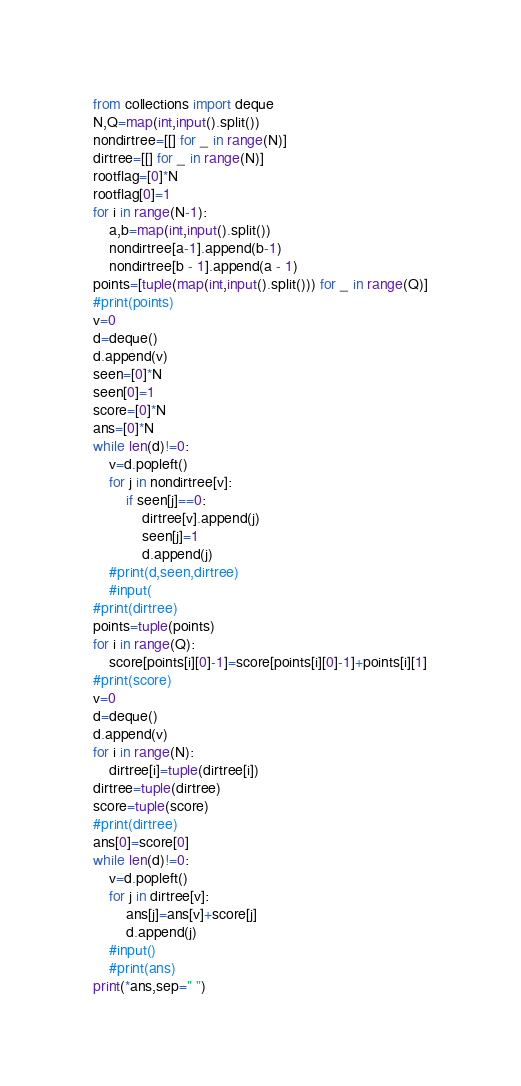<code> <loc_0><loc_0><loc_500><loc_500><_Python_>from collections import deque
N,Q=map(int,input().split())
nondirtree=[[] for _ in range(N)]
dirtree=[[] for _ in range(N)]
rootflag=[0]*N
rootflag[0]=1
for i in range(N-1):
    a,b=map(int,input().split())
    nondirtree[a-1].append(b-1)
    nondirtree[b - 1].append(a - 1)
points=[tuple(map(int,input().split())) for _ in range(Q)]
#print(points)
v=0
d=deque()
d.append(v)
seen=[0]*N
seen[0]=1
score=[0]*N
ans=[0]*N
while len(d)!=0:
    v=d.popleft()
    for j in nondirtree[v]:
        if seen[j]==0:
            dirtree[v].append(j)
            seen[j]=1
            d.append(j)
    #print(d,seen,dirtree)
    #input(
#print(dirtree)
points=tuple(points)
for i in range(Q):
    score[points[i][0]-1]=score[points[i][0]-1]+points[i][1]
#print(score)
v=0
d=deque()
d.append(v)
for i in range(N):
    dirtree[i]=tuple(dirtree[i])
dirtree=tuple(dirtree)
score=tuple(score)
#print(dirtree)
ans[0]=score[0]
while len(d)!=0:
    v=d.popleft()
    for j in dirtree[v]:
        ans[j]=ans[v]+score[j]
        d.append(j)
    #input()
    #print(ans)
print(*ans,sep=" ")
</code> 